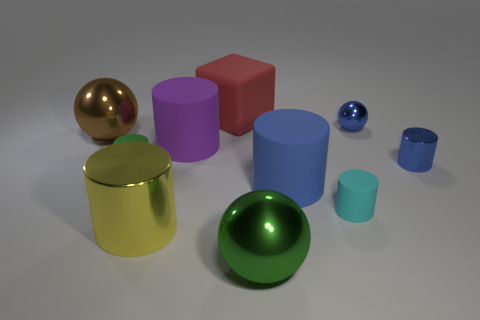Subtract 1 cylinders. How many cylinders are left? 5 Subtract all tiny green cylinders. How many cylinders are left? 5 Subtract all cyan cylinders. How many cylinders are left? 5 Subtract all blue cylinders. Subtract all yellow cubes. How many cylinders are left? 4 Subtract all spheres. How many objects are left? 7 Add 4 small objects. How many small objects exist? 8 Subtract 1 brown balls. How many objects are left? 9 Subtract all big cylinders. Subtract all big metal balls. How many objects are left? 5 Add 8 brown metal objects. How many brown metal objects are left? 9 